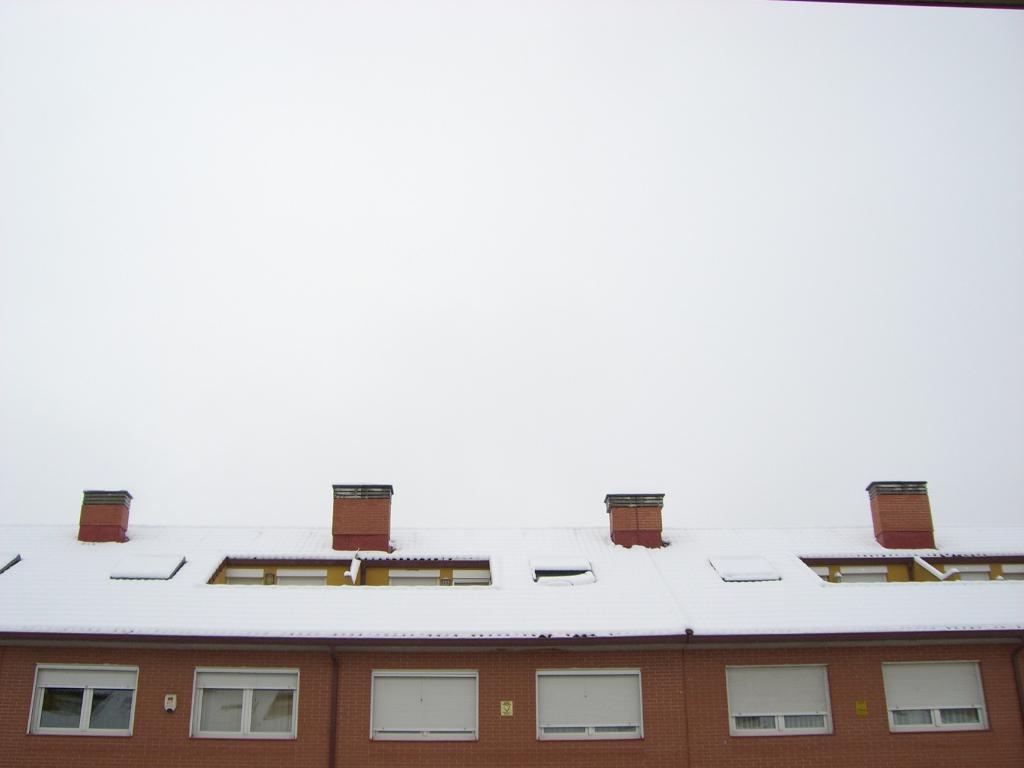In one or two sentences, can you explain what this image depicts? In this image we can see wooden house where the roof is covered with snow and the plain sky in the background. 